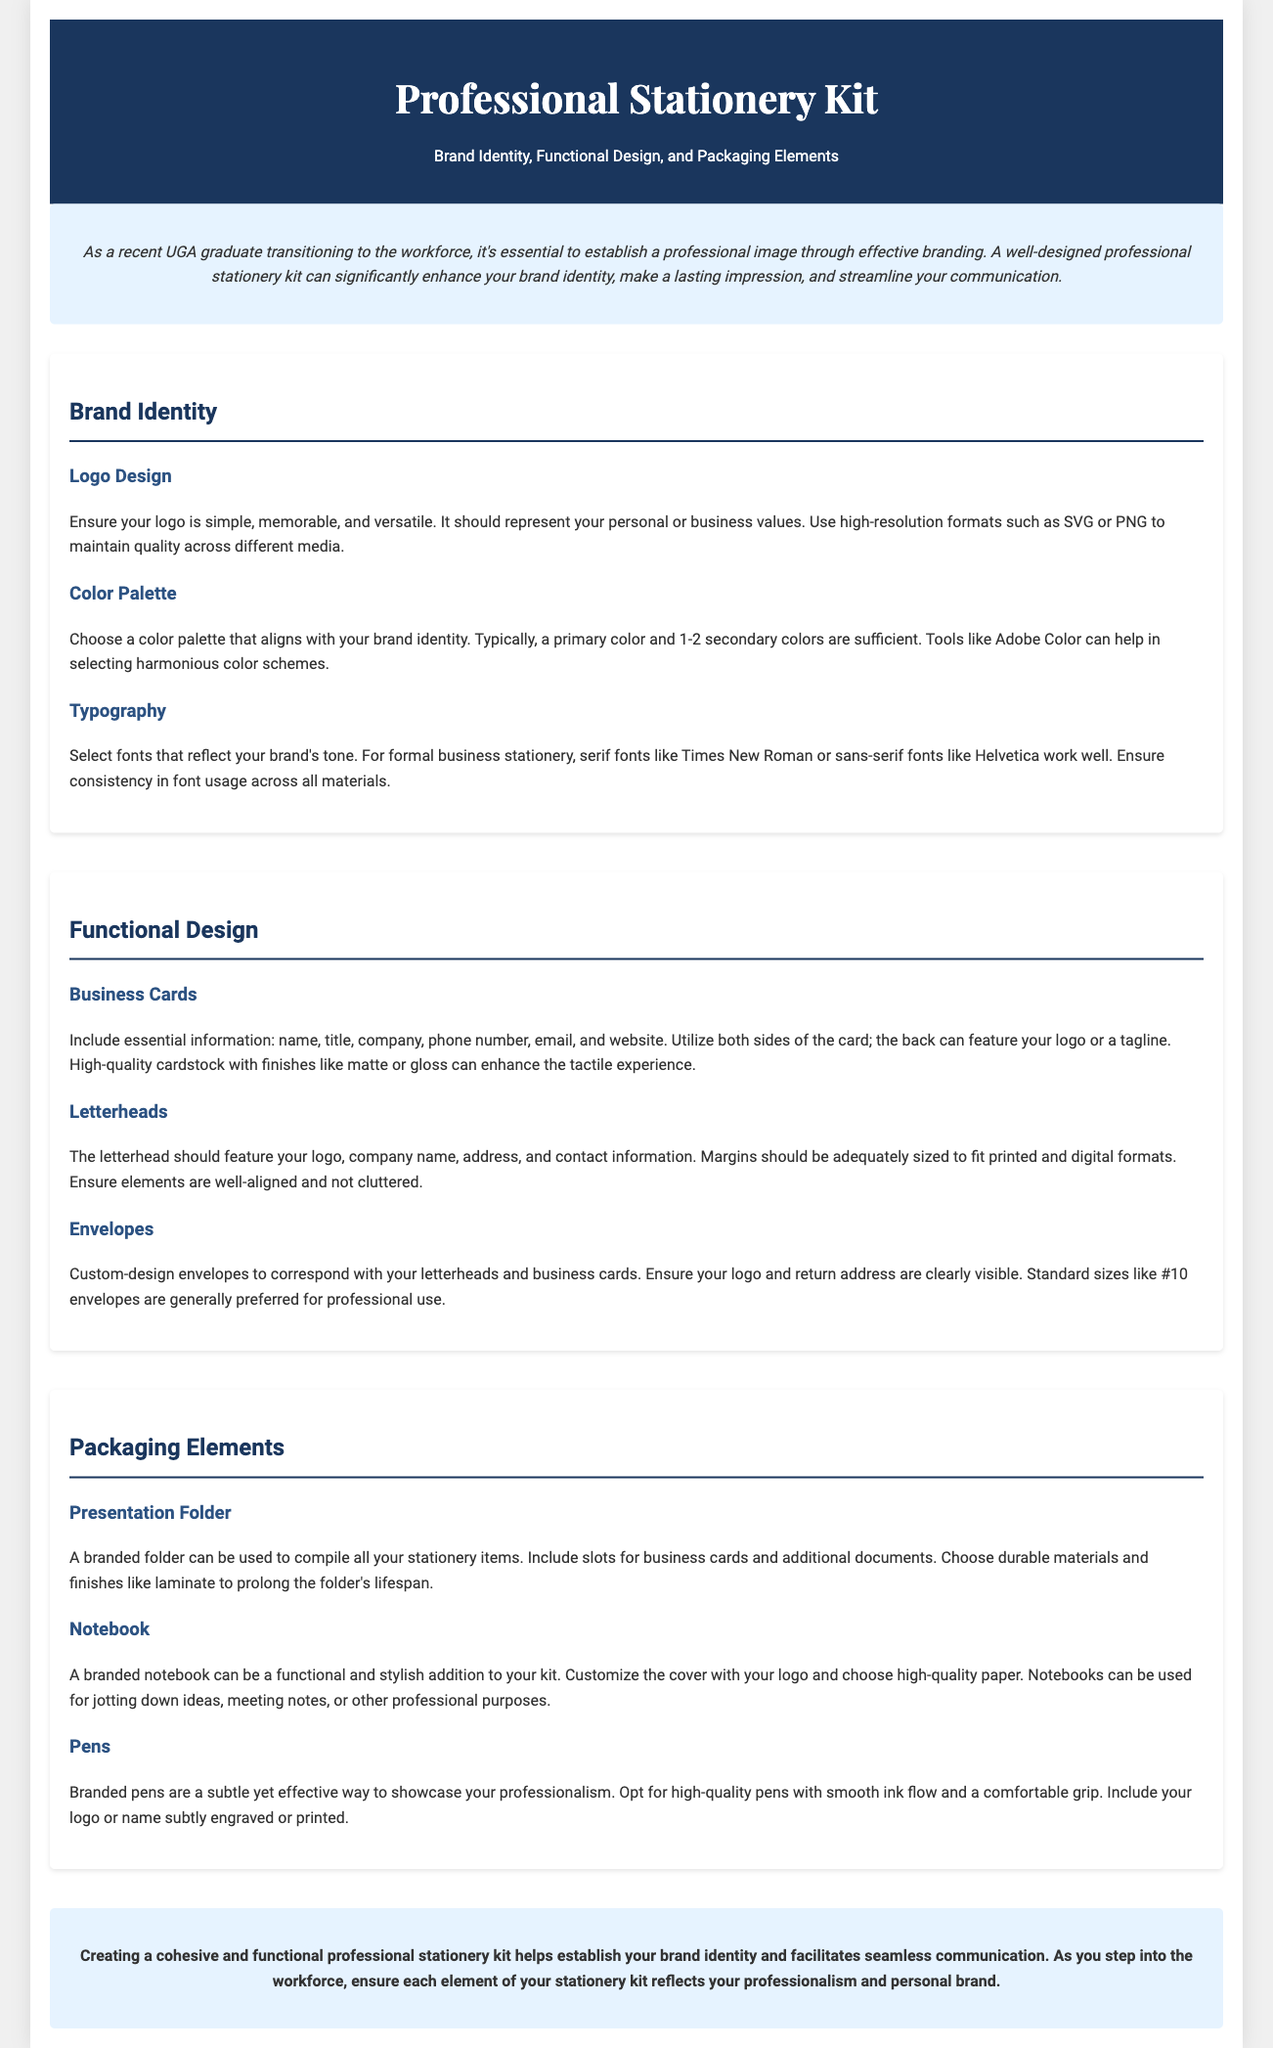What is the primary focus of the document? The document discusses the importance of a professional stationery kit in establishing brand identity and facilitating communication.
Answer: Professional stationery kit What colors are recommended for a color palette? The document suggests using a primary color and 1-2 secondary colors that align with your brand identity.
Answer: 1-2 secondary colors What should be included on a business card? The document lists essential information like name, title, company, phone number, email, and website that should be included on a business card.
Answer: Name, title, company, phone number, email, and website What material is recommended for a presentation folder? The document advises choosing durable materials and finishes like laminate for the presentation folder.
Answer: Durable materials and laminate How many fonts should you select for branding? The document suggests that selecting a few fonts that reflect your brand's tone is important for consistency, typically indicating a minimal number.
Answer: A few fonts What is the function of a branded notebook in the stationery kit? The document states that a branded notebook can be a functional and stylish addition used for various professional purposes.
Answer: Functional and stylish addition What does effective branding aim to establish? The document emphasizes that effective branding aims to establish a professional image as individuals transition to the workforce.
Answer: Professional image What does the conclusion emphasize about the stationery kit? The conclusion highlights the importance of creating a cohesive and functional stationery kit to establish brand identity and facilitate communication.
Answer: Cohesive and functional stationery kit 